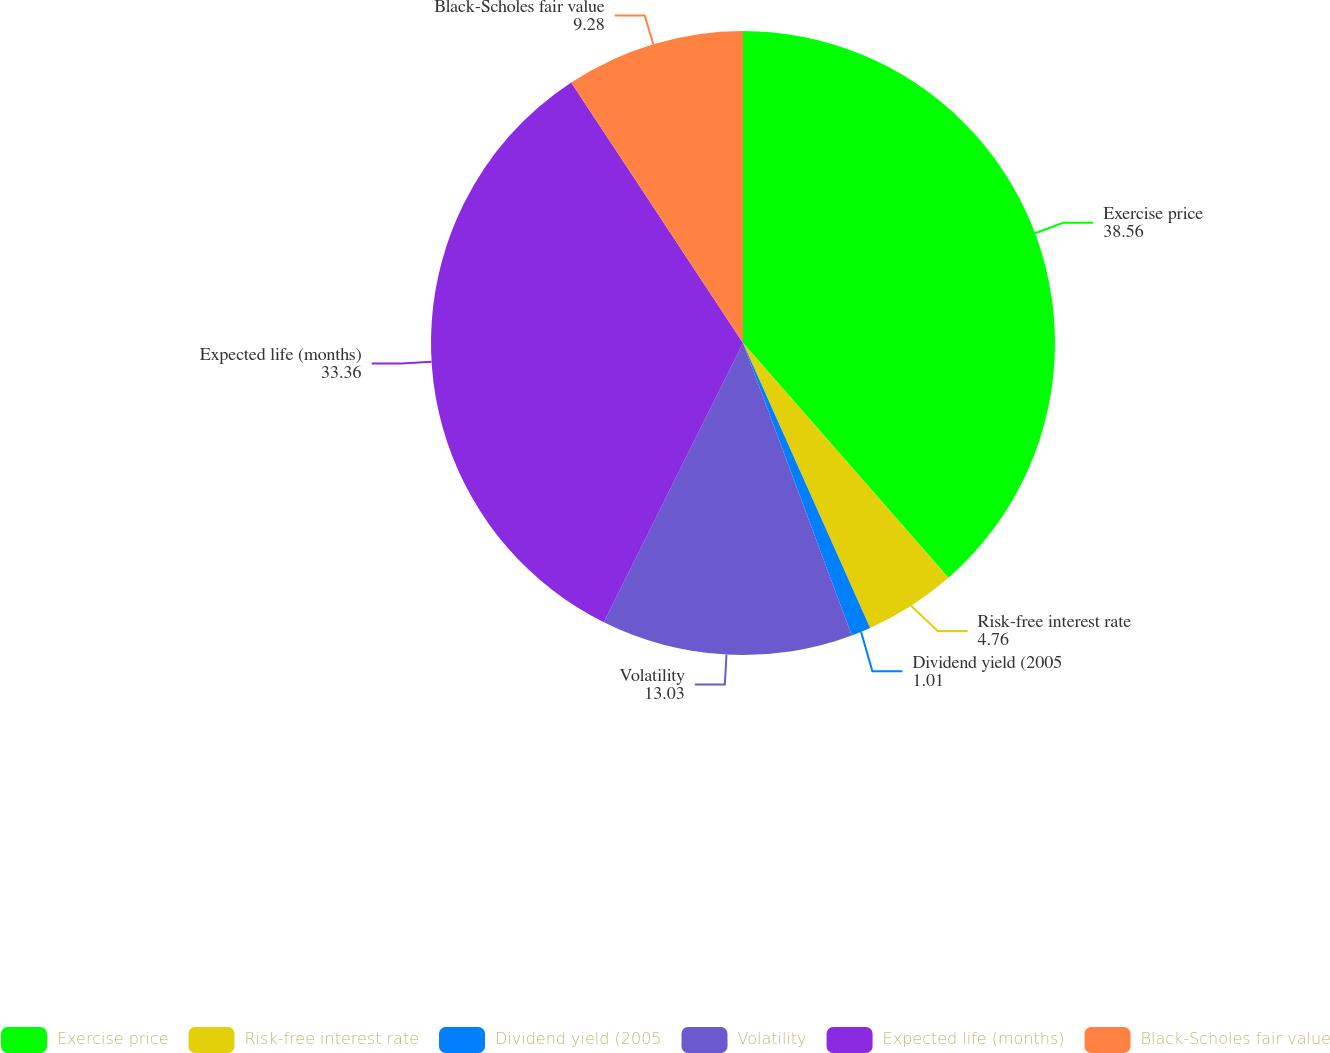Convert chart to OTSL. <chart><loc_0><loc_0><loc_500><loc_500><pie_chart><fcel>Exercise price<fcel>Risk-free interest rate<fcel>Dividend yield (2005<fcel>Volatility<fcel>Expected life (months)<fcel>Black-Scholes fair value<nl><fcel>38.56%<fcel>4.76%<fcel>1.01%<fcel>13.03%<fcel>33.36%<fcel>9.28%<nl></chart> 